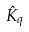<formula> <loc_0><loc_0><loc_500><loc_500>\hat { K } _ { q }</formula> 